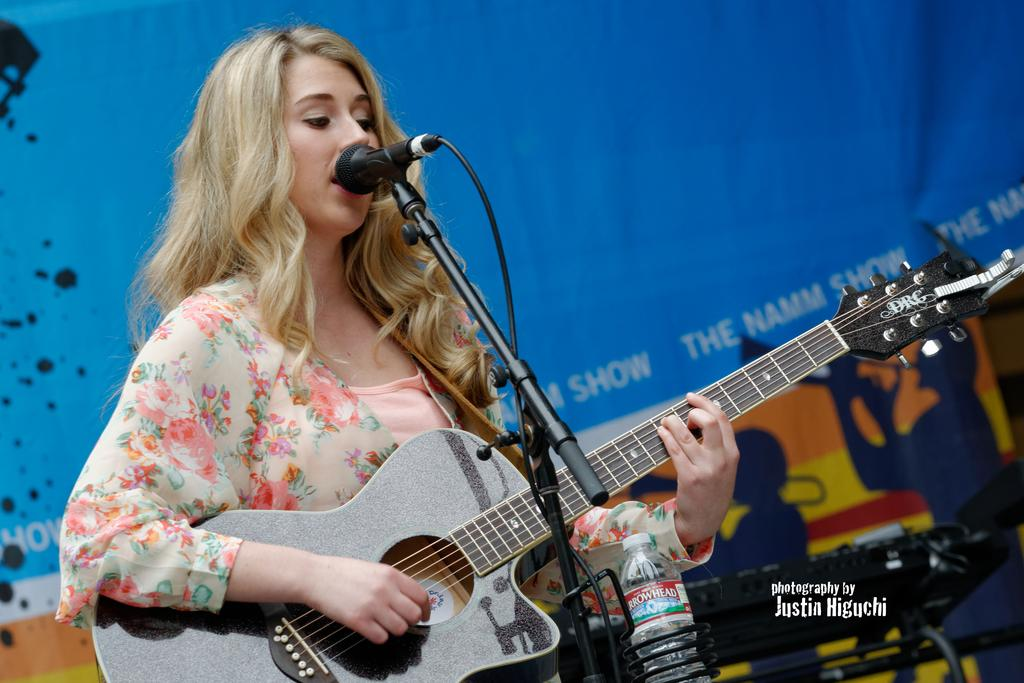What is the main subject of the image? The main subject of the image is a woman. What is the woman doing in the image? The woman is standing, playing a guitar, and singing into a microphone. Can you describe any objects in the image? Yes, there is a bottle in the bottom right side of the image and a banner behind the woman. What type of car can be seen in the background of the image? There is no car present in the image; it features a woman playing a guitar and singing into a microphone, with a bottle and banner nearby. 